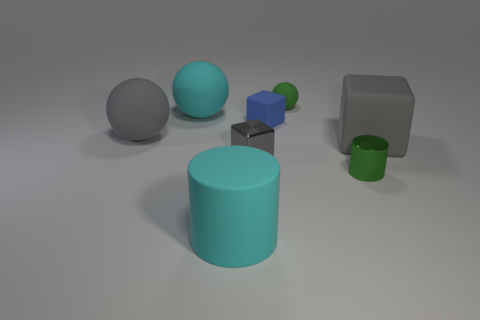What material is the thing behind the big matte ball that is on the right side of the big gray matte ball?
Offer a very short reply. Rubber. There is a tiny thing that is the same color as the tiny cylinder; what shape is it?
Provide a short and direct response. Sphere. There is a shiny thing that is the same size as the green metallic cylinder; what shape is it?
Your response must be concise. Cube. Are there fewer small green spheres than yellow things?
Your answer should be very brief. No. There is a large gray rubber object on the right side of the gray sphere; is there a gray rubber object to the left of it?
Offer a terse response. Yes. What is the shape of the green thing that is the same material as the tiny blue cube?
Offer a very short reply. Sphere. Is there any other thing of the same color as the large matte cylinder?
Ensure brevity in your answer.  Yes. There is a large cyan thing that is the same shape as the small green matte object; what is its material?
Keep it short and to the point. Rubber. What number of other things are there of the same size as the cyan cylinder?
Give a very brief answer. 3. What size is the object that is the same color as the big cylinder?
Make the answer very short. Large. 